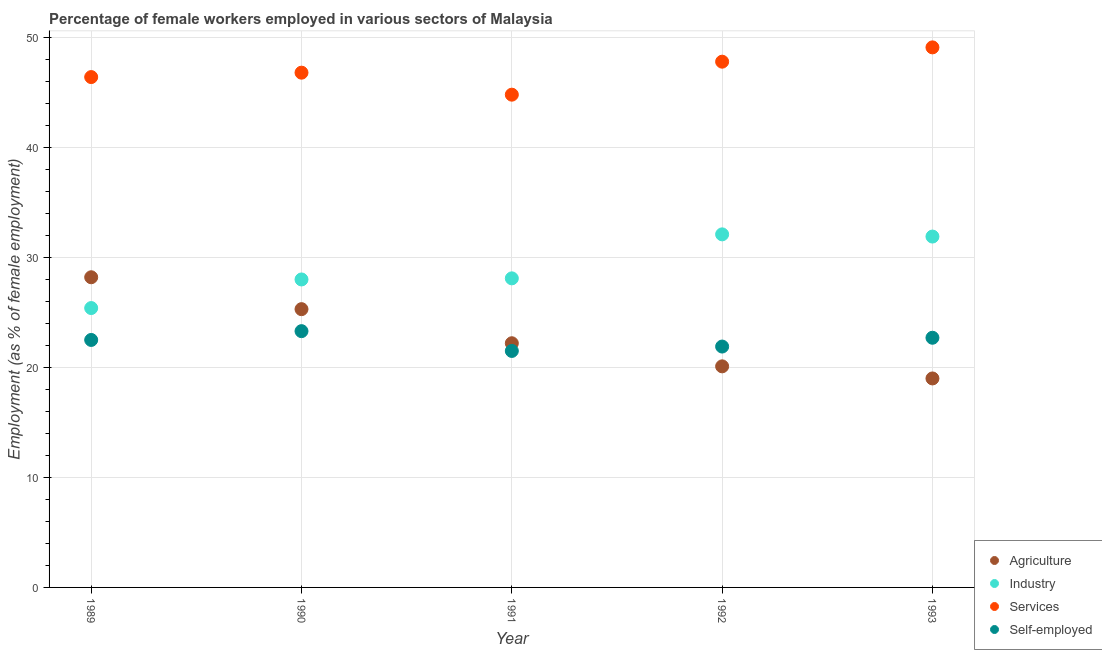How many different coloured dotlines are there?
Give a very brief answer. 4. What is the percentage of female workers in industry in 1990?
Your answer should be compact. 28. Across all years, what is the maximum percentage of female workers in services?
Offer a terse response. 49.1. Across all years, what is the minimum percentage of female workers in industry?
Offer a very short reply. 25.4. In which year was the percentage of female workers in agriculture minimum?
Offer a very short reply. 1993. What is the total percentage of female workers in services in the graph?
Provide a short and direct response. 234.9. What is the difference between the percentage of female workers in agriculture in 1990 and that in 1993?
Your answer should be very brief. 6.3. What is the difference between the percentage of female workers in services in 1989 and the percentage of female workers in industry in 1993?
Your answer should be very brief. 14.5. What is the average percentage of female workers in services per year?
Give a very brief answer. 46.98. In the year 1991, what is the difference between the percentage of self employed female workers and percentage of female workers in agriculture?
Keep it short and to the point. -0.7. In how many years, is the percentage of female workers in agriculture greater than 14 %?
Provide a short and direct response. 5. What is the ratio of the percentage of self employed female workers in 1989 to that in 1991?
Your response must be concise. 1.05. Is the difference between the percentage of female workers in services in 1992 and 1993 greater than the difference between the percentage of female workers in industry in 1992 and 1993?
Provide a succinct answer. No. What is the difference between the highest and the second highest percentage of self employed female workers?
Give a very brief answer. 0.6. What is the difference between the highest and the lowest percentage of female workers in industry?
Provide a succinct answer. 6.7. Is the sum of the percentage of female workers in agriculture in 1989 and 1990 greater than the maximum percentage of female workers in industry across all years?
Your response must be concise. Yes. Is the percentage of self employed female workers strictly greater than the percentage of female workers in industry over the years?
Your answer should be compact. No. How many dotlines are there?
Give a very brief answer. 4. What is the difference between two consecutive major ticks on the Y-axis?
Provide a short and direct response. 10. Does the graph contain grids?
Offer a terse response. Yes. How many legend labels are there?
Your response must be concise. 4. How are the legend labels stacked?
Give a very brief answer. Vertical. What is the title of the graph?
Your response must be concise. Percentage of female workers employed in various sectors of Malaysia. Does "Japan" appear as one of the legend labels in the graph?
Give a very brief answer. No. What is the label or title of the Y-axis?
Keep it short and to the point. Employment (as % of female employment). What is the Employment (as % of female employment) of Agriculture in 1989?
Offer a terse response. 28.2. What is the Employment (as % of female employment) in Industry in 1989?
Make the answer very short. 25.4. What is the Employment (as % of female employment) of Services in 1989?
Offer a very short reply. 46.4. What is the Employment (as % of female employment) in Self-employed in 1989?
Give a very brief answer. 22.5. What is the Employment (as % of female employment) of Agriculture in 1990?
Your response must be concise. 25.3. What is the Employment (as % of female employment) of Industry in 1990?
Your answer should be very brief. 28. What is the Employment (as % of female employment) of Services in 1990?
Your answer should be compact. 46.8. What is the Employment (as % of female employment) of Self-employed in 1990?
Provide a succinct answer. 23.3. What is the Employment (as % of female employment) of Agriculture in 1991?
Your response must be concise. 22.2. What is the Employment (as % of female employment) in Industry in 1991?
Offer a very short reply. 28.1. What is the Employment (as % of female employment) in Services in 1991?
Offer a terse response. 44.8. What is the Employment (as % of female employment) of Agriculture in 1992?
Keep it short and to the point. 20.1. What is the Employment (as % of female employment) of Industry in 1992?
Offer a terse response. 32.1. What is the Employment (as % of female employment) in Services in 1992?
Give a very brief answer. 47.8. What is the Employment (as % of female employment) of Self-employed in 1992?
Keep it short and to the point. 21.9. What is the Employment (as % of female employment) in Agriculture in 1993?
Ensure brevity in your answer.  19. What is the Employment (as % of female employment) of Industry in 1993?
Ensure brevity in your answer.  31.9. What is the Employment (as % of female employment) of Services in 1993?
Your answer should be very brief. 49.1. What is the Employment (as % of female employment) of Self-employed in 1993?
Provide a succinct answer. 22.7. Across all years, what is the maximum Employment (as % of female employment) in Agriculture?
Your response must be concise. 28.2. Across all years, what is the maximum Employment (as % of female employment) in Industry?
Your response must be concise. 32.1. Across all years, what is the maximum Employment (as % of female employment) of Services?
Your answer should be very brief. 49.1. Across all years, what is the maximum Employment (as % of female employment) of Self-employed?
Your answer should be very brief. 23.3. Across all years, what is the minimum Employment (as % of female employment) in Agriculture?
Provide a short and direct response. 19. Across all years, what is the minimum Employment (as % of female employment) of Industry?
Provide a short and direct response. 25.4. Across all years, what is the minimum Employment (as % of female employment) in Services?
Provide a short and direct response. 44.8. Across all years, what is the minimum Employment (as % of female employment) in Self-employed?
Offer a very short reply. 21.5. What is the total Employment (as % of female employment) of Agriculture in the graph?
Your answer should be compact. 114.8. What is the total Employment (as % of female employment) in Industry in the graph?
Your answer should be compact. 145.5. What is the total Employment (as % of female employment) in Services in the graph?
Make the answer very short. 234.9. What is the total Employment (as % of female employment) in Self-employed in the graph?
Offer a terse response. 111.9. What is the difference between the Employment (as % of female employment) in Agriculture in 1989 and that in 1990?
Offer a very short reply. 2.9. What is the difference between the Employment (as % of female employment) in Industry in 1989 and that in 1990?
Ensure brevity in your answer.  -2.6. What is the difference between the Employment (as % of female employment) in Services in 1989 and that in 1990?
Your answer should be very brief. -0.4. What is the difference between the Employment (as % of female employment) of Self-employed in 1989 and that in 1990?
Your answer should be compact. -0.8. What is the difference between the Employment (as % of female employment) in Agriculture in 1989 and that in 1991?
Your answer should be very brief. 6. What is the difference between the Employment (as % of female employment) of Agriculture in 1989 and that in 1992?
Give a very brief answer. 8.1. What is the difference between the Employment (as % of female employment) in Industry in 1989 and that in 1992?
Give a very brief answer. -6.7. What is the difference between the Employment (as % of female employment) of Services in 1989 and that in 1992?
Offer a very short reply. -1.4. What is the difference between the Employment (as % of female employment) in Agriculture in 1989 and that in 1993?
Your answer should be very brief. 9.2. What is the difference between the Employment (as % of female employment) in Industry in 1989 and that in 1993?
Give a very brief answer. -6.5. What is the difference between the Employment (as % of female employment) in Industry in 1990 and that in 1991?
Give a very brief answer. -0.1. What is the difference between the Employment (as % of female employment) of Services in 1990 and that in 1991?
Make the answer very short. 2. What is the difference between the Employment (as % of female employment) in Self-employed in 1990 and that in 1991?
Keep it short and to the point. 1.8. What is the difference between the Employment (as % of female employment) of Industry in 1990 and that in 1992?
Give a very brief answer. -4.1. What is the difference between the Employment (as % of female employment) in Self-employed in 1990 and that in 1992?
Offer a terse response. 1.4. What is the difference between the Employment (as % of female employment) of Industry in 1990 and that in 1993?
Your answer should be compact. -3.9. What is the difference between the Employment (as % of female employment) in Services in 1990 and that in 1993?
Give a very brief answer. -2.3. What is the difference between the Employment (as % of female employment) in Agriculture in 1991 and that in 1992?
Your response must be concise. 2.1. What is the difference between the Employment (as % of female employment) in Self-employed in 1991 and that in 1992?
Make the answer very short. -0.4. What is the difference between the Employment (as % of female employment) in Self-employed in 1991 and that in 1993?
Provide a succinct answer. -1.2. What is the difference between the Employment (as % of female employment) of Agriculture in 1992 and that in 1993?
Provide a short and direct response. 1.1. What is the difference between the Employment (as % of female employment) of Services in 1992 and that in 1993?
Offer a terse response. -1.3. What is the difference between the Employment (as % of female employment) in Agriculture in 1989 and the Employment (as % of female employment) in Services in 1990?
Keep it short and to the point. -18.6. What is the difference between the Employment (as % of female employment) of Agriculture in 1989 and the Employment (as % of female employment) of Self-employed in 1990?
Offer a terse response. 4.9. What is the difference between the Employment (as % of female employment) in Industry in 1989 and the Employment (as % of female employment) in Services in 1990?
Your answer should be compact. -21.4. What is the difference between the Employment (as % of female employment) in Industry in 1989 and the Employment (as % of female employment) in Self-employed in 1990?
Your answer should be compact. 2.1. What is the difference between the Employment (as % of female employment) of Services in 1989 and the Employment (as % of female employment) of Self-employed in 1990?
Keep it short and to the point. 23.1. What is the difference between the Employment (as % of female employment) in Agriculture in 1989 and the Employment (as % of female employment) in Services in 1991?
Your answer should be compact. -16.6. What is the difference between the Employment (as % of female employment) of Agriculture in 1989 and the Employment (as % of female employment) of Self-employed in 1991?
Provide a short and direct response. 6.7. What is the difference between the Employment (as % of female employment) of Industry in 1989 and the Employment (as % of female employment) of Services in 1991?
Your answer should be very brief. -19.4. What is the difference between the Employment (as % of female employment) of Services in 1989 and the Employment (as % of female employment) of Self-employed in 1991?
Make the answer very short. 24.9. What is the difference between the Employment (as % of female employment) of Agriculture in 1989 and the Employment (as % of female employment) of Services in 1992?
Offer a very short reply. -19.6. What is the difference between the Employment (as % of female employment) of Industry in 1989 and the Employment (as % of female employment) of Services in 1992?
Ensure brevity in your answer.  -22.4. What is the difference between the Employment (as % of female employment) of Industry in 1989 and the Employment (as % of female employment) of Self-employed in 1992?
Your answer should be compact. 3.5. What is the difference between the Employment (as % of female employment) of Services in 1989 and the Employment (as % of female employment) of Self-employed in 1992?
Your answer should be compact. 24.5. What is the difference between the Employment (as % of female employment) in Agriculture in 1989 and the Employment (as % of female employment) in Services in 1993?
Provide a succinct answer. -20.9. What is the difference between the Employment (as % of female employment) of Industry in 1989 and the Employment (as % of female employment) of Services in 1993?
Offer a terse response. -23.7. What is the difference between the Employment (as % of female employment) of Industry in 1989 and the Employment (as % of female employment) of Self-employed in 1993?
Keep it short and to the point. 2.7. What is the difference between the Employment (as % of female employment) of Services in 1989 and the Employment (as % of female employment) of Self-employed in 1993?
Keep it short and to the point. 23.7. What is the difference between the Employment (as % of female employment) of Agriculture in 1990 and the Employment (as % of female employment) of Industry in 1991?
Offer a terse response. -2.8. What is the difference between the Employment (as % of female employment) in Agriculture in 1990 and the Employment (as % of female employment) in Services in 1991?
Provide a short and direct response. -19.5. What is the difference between the Employment (as % of female employment) of Agriculture in 1990 and the Employment (as % of female employment) of Self-employed in 1991?
Make the answer very short. 3.8. What is the difference between the Employment (as % of female employment) in Industry in 1990 and the Employment (as % of female employment) in Services in 1991?
Offer a terse response. -16.8. What is the difference between the Employment (as % of female employment) of Services in 1990 and the Employment (as % of female employment) of Self-employed in 1991?
Make the answer very short. 25.3. What is the difference between the Employment (as % of female employment) in Agriculture in 1990 and the Employment (as % of female employment) in Industry in 1992?
Ensure brevity in your answer.  -6.8. What is the difference between the Employment (as % of female employment) of Agriculture in 1990 and the Employment (as % of female employment) of Services in 1992?
Your response must be concise. -22.5. What is the difference between the Employment (as % of female employment) of Agriculture in 1990 and the Employment (as % of female employment) of Self-employed in 1992?
Keep it short and to the point. 3.4. What is the difference between the Employment (as % of female employment) in Industry in 1990 and the Employment (as % of female employment) in Services in 1992?
Your response must be concise. -19.8. What is the difference between the Employment (as % of female employment) in Industry in 1990 and the Employment (as % of female employment) in Self-employed in 1992?
Offer a very short reply. 6.1. What is the difference between the Employment (as % of female employment) in Services in 1990 and the Employment (as % of female employment) in Self-employed in 1992?
Offer a terse response. 24.9. What is the difference between the Employment (as % of female employment) of Agriculture in 1990 and the Employment (as % of female employment) of Services in 1993?
Your response must be concise. -23.8. What is the difference between the Employment (as % of female employment) of Agriculture in 1990 and the Employment (as % of female employment) of Self-employed in 1993?
Give a very brief answer. 2.6. What is the difference between the Employment (as % of female employment) of Industry in 1990 and the Employment (as % of female employment) of Services in 1993?
Offer a very short reply. -21.1. What is the difference between the Employment (as % of female employment) in Services in 1990 and the Employment (as % of female employment) in Self-employed in 1993?
Provide a short and direct response. 24.1. What is the difference between the Employment (as % of female employment) in Agriculture in 1991 and the Employment (as % of female employment) in Services in 1992?
Offer a very short reply. -25.6. What is the difference between the Employment (as % of female employment) in Agriculture in 1991 and the Employment (as % of female employment) in Self-employed in 1992?
Offer a terse response. 0.3. What is the difference between the Employment (as % of female employment) in Industry in 1991 and the Employment (as % of female employment) in Services in 1992?
Ensure brevity in your answer.  -19.7. What is the difference between the Employment (as % of female employment) of Industry in 1991 and the Employment (as % of female employment) of Self-employed in 1992?
Ensure brevity in your answer.  6.2. What is the difference between the Employment (as % of female employment) of Services in 1991 and the Employment (as % of female employment) of Self-employed in 1992?
Your answer should be very brief. 22.9. What is the difference between the Employment (as % of female employment) in Agriculture in 1991 and the Employment (as % of female employment) in Industry in 1993?
Offer a terse response. -9.7. What is the difference between the Employment (as % of female employment) in Agriculture in 1991 and the Employment (as % of female employment) in Services in 1993?
Ensure brevity in your answer.  -26.9. What is the difference between the Employment (as % of female employment) of Agriculture in 1991 and the Employment (as % of female employment) of Self-employed in 1993?
Offer a very short reply. -0.5. What is the difference between the Employment (as % of female employment) in Industry in 1991 and the Employment (as % of female employment) in Services in 1993?
Provide a short and direct response. -21. What is the difference between the Employment (as % of female employment) in Industry in 1991 and the Employment (as % of female employment) in Self-employed in 1993?
Keep it short and to the point. 5.4. What is the difference between the Employment (as % of female employment) of Services in 1991 and the Employment (as % of female employment) of Self-employed in 1993?
Ensure brevity in your answer.  22.1. What is the difference between the Employment (as % of female employment) in Agriculture in 1992 and the Employment (as % of female employment) in Industry in 1993?
Provide a short and direct response. -11.8. What is the difference between the Employment (as % of female employment) of Agriculture in 1992 and the Employment (as % of female employment) of Services in 1993?
Offer a terse response. -29. What is the difference between the Employment (as % of female employment) of Industry in 1992 and the Employment (as % of female employment) of Self-employed in 1993?
Your answer should be compact. 9.4. What is the difference between the Employment (as % of female employment) in Services in 1992 and the Employment (as % of female employment) in Self-employed in 1993?
Provide a succinct answer. 25.1. What is the average Employment (as % of female employment) of Agriculture per year?
Offer a very short reply. 22.96. What is the average Employment (as % of female employment) of Industry per year?
Your answer should be compact. 29.1. What is the average Employment (as % of female employment) of Services per year?
Keep it short and to the point. 46.98. What is the average Employment (as % of female employment) in Self-employed per year?
Ensure brevity in your answer.  22.38. In the year 1989, what is the difference between the Employment (as % of female employment) of Agriculture and Employment (as % of female employment) of Services?
Give a very brief answer. -18.2. In the year 1989, what is the difference between the Employment (as % of female employment) in Agriculture and Employment (as % of female employment) in Self-employed?
Ensure brevity in your answer.  5.7. In the year 1989, what is the difference between the Employment (as % of female employment) in Industry and Employment (as % of female employment) in Services?
Provide a succinct answer. -21. In the year 1989, what is the difference between the Employment (as % of female employment) in Industry and Employment (as % of female employment) in Self-employed?
Your response must be concise. 2.9. In the year 1989, what is the difference between the Employment (as % of female employment) in Services and Employment (as % of female employment) in Self-employed?
Ensure brevity in your answer.  23.9. In the year 1990, what is the difference between the Employment (as % of female employment) in Agriculture and Employment (as % of female employment) in Services?
Make the answer very short. -21.5. In the year 1990, what is the difference between the Employment (as % of female employment) in Agriculture and Employment (as % of female employment) in Self-employed?
Make the answer very short. 2. In the year 1990, what is the difference between the Employment (as % of female employment) in Industry and Employment (as % of female employment) in Services?
Provide a short and direct response. -18.8. In the year 1990, what is the difference between the Employment (as % of female employment) in Industry and Employment (as % of female employment) in Self-employed?
Your response must be concise. 4.7. In the year 1990, what is the difference between the Employment (as % of female employment) of Services and Employment (as % of female employment) of Self-employed?
Your answer should be very brief. 23.5. In the year 1991, what is the difference between the Employment (as % of female employment) of Agriculture and Employment (as % of female employment) of Industry?
Your answer should be compact. -5.9. In the year 1991, what is the difference between the Employment (as % of female employment) of Agriculture and Employment (as % of female employment) of Services?
Your answer should be compact. -22.6. In the year 1991, what is the difference between the Employment (as % of female employment) of Industry and Employment (as % of female employment) of Services?
Give a very brief answer. -16.7. In the year 1991, what is the difference between the Employment (as % of female employment) of Services and Employment (as % of female employment) of Self-employed?
Make the answer very short. 23.3. In the year 1992, what is the difference between the Employment (as % of female employment) of Agriculture and Employment (as % of female employment) of Industry?
Offer a very short reply. -12. In the year 1992, what is the difference between the Employment (as % of female employment) of Agriculture and Employment (as % of female employment) of Services?
Provide a succinct answer. -27.7. In the year 1992, what is the difference between the Employment (as % of female employment) in Agriculture and Employment (as % of female employment) in Self-employed?
Make the answer very short. -1.8. In the year 1992, what is the difference between the Employment (as % of female employment) of Industry and Employment (as % of female employment) of Services?
Offer a terse response. -15.7. In the year 1992, what is the difference between the Employment (as % of female employment) of Industry and Employment (as % of female employment) of Self-employed?
Keep it short and to the point. 10.2. In the year 1992, what is the difference between the Employment (as % of female employment) of Services and Employment (as % of female employment) of Self-employed?
Give a very brief answer. 25.9. In the year 1993, what is the difference between the Employment (as % of female employment) in Agriculture and Employment (as % of female employment) in Industry?
Ensure brevity in your answer.  -12.9. In the year 1993, what is the difference between the Employment (as % of female employment) of Agriculture and Employment (as % of female employment) of Services?
Your answer should be very brief. -30.1. In the year 1993, what is the difference between the Employment (as % of female employment) of Agriculture and Employment (as % of female employment) of Self-employed?
Provide a succinct answer. -3.7. In the year 1993, what is the difference between the Employment (as % of female employment) in Industry and Employment (as % of female employment) in Services?
Provide a short and direct response. -17.2. In the year 1993, what is the difference between the Employment (as % of female employment) of Services and Employment (as % of female employment) of Self-employed?
Provide a succinct answer. 26.4. What is the ratio of the Employment (as % of female employment) in Agriculture in 1989 to that in 1990?
Your answer should be compact. 1.11. What is the ratio of the Employment (as % of female employment) in Industry in 1989 to that in 1990?
Make the answer very short. 0.91. What is the ratio of the Employment (as % of female employment) of Self-employed in 1989 to that in 1990?
Offer a terse response. 0.97. What is the ratio of the Employment (as % of female employment) of Agriculture in 1989 to that in 1991?
Your answer should be compact. 1.27. What is the ratio of the Employment (as % of female employment) of Industry in 1989 to that in 1991?
Ensure brevity in your answer.  0.9. What is the ratio of the Employment (as % of female employment) of Services in 1989 to that in 1991?
Offer a very short reply. 1.04. What is the ratio of the Employment (as % of female employment) in Self-employed in 1989 to that in 1991?
Give a very brief answer. 1.05. What is the ratio of the Employment (as % of female employment) of Agriculture in 1989 to that in 1992?
Your response must be concise. 1.4. What is the ratio of the Employment (as % of female employment) in Industry in 1989 to that in 1992?
Your answer should be compact. 0.79. What is the ratio of the Employment (as % of female employment) of Services in 1989 to that in 1992?
Ensure brevity in your answer.  0.97. What is the ratio of the Employment (as % of female employment) of Self-employed in 1989 to that in 1992?
Give a very brief answer. 1.03. What is the ratio of the Employment (as % of female employment) of Agriculture in 1989 to that in 1993?
Offer a terse response. 1.48. What is the ratio of the Employment (as % of female employment) in Industry in 1989 to that in 1993?
Give a very brief answer. 0.8. What is the ratio of the Employment (as % of female employment) of Services in 1989 to that in 1993?
Offer a terse response. 0.94. What is the ratio of the Employment (as % of female employment) of Agriculture in 1990 to that in 1991?
Your answer should be very brief. 1.14. What is the ratio of the Employment (as % of female employment) in Industry in 1990 to that in 1991?
Keep it short and to the point. 1. What is the ratio of the Employment (as % of female employment) in Services in 1990 to that in 1991?
Your answer should be compact. 1.04. What is the ratio of the Employment (as % of female employment) in Self-employed in 1990 to that in 1991?
Provide a short and direct response. 1.08. What is the ratio of the Employment (as % of female employment) in Agriculture in 1990 to that in 1992?
Make the answer very short. 1.26. What is the ratio of the Employment (as % of female employment) in Industry in 1990 to that in 1992?
Your answer should be compact. 0.87. What is the ratio of the Employment (as % of female employment) in Services in 1990 to that in 1992?
Provide a succinct answer. 0.98. What is the ratio of the Employment (as % of female employment) of Self-employed in 1990 to that in 1992?
Offer a terse response. 1.06. What is the ratio of the Employment (as % of female employment) of Agriculture in 1990 to that in 1993?
Your response must be concise. 1.33. What is the ratio of the Employment (as % of female employment) of Industry in 1990 to that in 1993?
Your answer should be very brief. 0.88. What is the ratio of the Employment (as % of female employment) in Services in 1990 to that in 1993?
Keep it short and to the point. 0.95. What is the ratio of the Employment (as % of female employment) in Self-employed in 1990 to that in 1993?
Your response must be concise. 1.03. What is the ratio of the Employment (as % of female employment) in Agriculture in 1991 to that in 1992?
Your answer should be compact. 1.1. What is the ratio of the Employment (as % of female employment) in Industry in 1991 to that in 1992?
Provide a short and direct response. 0.88. What is the ratio of the Employment (as % of female employment) in Services in 1991 to that in 1992?
Offer a very short reply. 0.94. What is the ratio of the Employment (as % of female employment) of Self-employed in 1991 to that in 1992?
Make the answer very short. 0.98. What is the ratio of the Employment (as % of female employment) in Agriculture in 1991 to that in 1993?
Offer a terse response. 1.17. What is the ratio of the Employment (as % of female employment) in Industry in 1991 to that in 1993?
Keep it short and to the point. 0.88. What is the ratio of the Employment (as % of female employment) in Services in 1991 to that in 1993?
Your answer should be compact. 0.91. What is the ratio of the Employment (as % of female employment) in Self-employed in 1991 to that in 1993?
Provide a succinct answer. 0.95. What is the ratio of the Employment (as % of female employment) in Agriculture in 1992 to that in 1993?
Your answer should be very brief. 1.06. What is the ratio of the Employment (as % of female employment) in Industry in 1992 to that in 1993?
Your answer should be compact. 1.01. What is the ratio of the Employment (as % of female employment) of Services in 1992 to that in 1993?
Offer a very short reply. 0.97. What is the ratio of the Employment (as % of female employment) in Self-employed in 1992 to that in 1993?
Your response must be concise. 0.96. What is the difference between the highest and the second highest Employment (as % of female employment) of Industry?
Keep it short and to the point. 0.2. What is the difference between the highest and the second highest Employment (as % of female employment) in Services?
Make the answer very short. 1.3. What is the difference between the highest and the lowest Employment (as % of female employment) in Agriculture?
Your answer should be very brief. 9.2. 